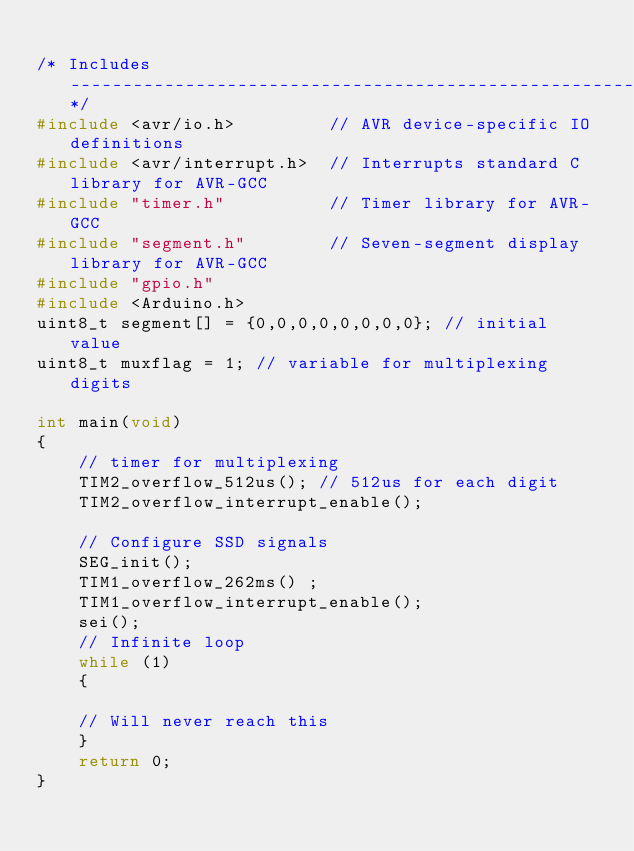<code> <loc_0><loc_0><loc_500><loc_500><_C++_>
/* Includes ----------------------------------------------------------*/
#include <avr/io.h>         // AVR device-specific IO definitions
#include <avr/interrupt.h>  // Interrupts standard C library for AVR-GCC
#include "timer.h"          // Timer library for AVR-GCC
#include "segment.h"        // Seven-segment display library for AVR-GCC
#include "gpio.h"
#include <Arduino.h>
uint8_t segment[] = {0,0,0,0,0,0,0,0}; // initial value
uint8_t muxflag = 1; // variable for multiplexing digits

int main(void)
{
    // timer for multiplexing
    TIM2_overflow_512us(); // 512us for each digit
    TIM2_overflow_interrupt_enable();

    // Configure SSD signals
    SEG_init();
    TIM1_overflow_262ms() ;
    TIM1_overflow_interrupt_enable();
    sei();
    // Infinite loop
    while (1)
    {

    // Will never reach this    
    }
    return 0;
}
</code> 